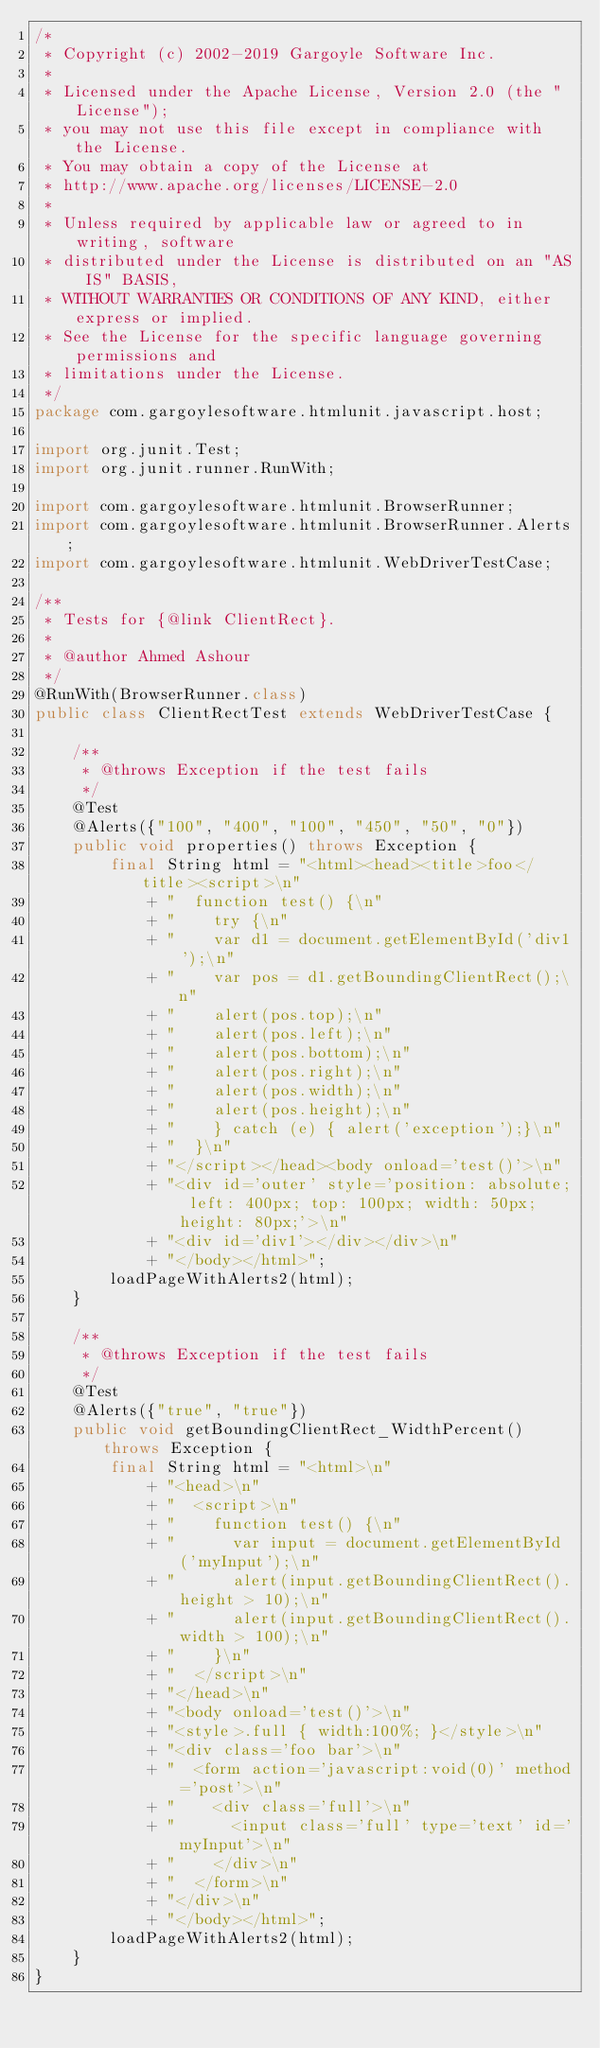<code> <loc_0><loc_0><loc_500><loc_500><_Java_>/*
 * Copyright (c) 2002-2019 Gargoyle Software Inc.
 *
 * Licensed under the Apache License, Version 2.0 (the "License");
 * you may not use this file except in compliance with the License.
 * You may obtain a copy of the License at
 * http://www.apache.org/licenses/LICENSE-2.0
 *
 * Unless required by applicable law or agreed to in writing, software
 * distributed under the License is distributed on an "AS IS" BASIS,
 * WITHOUT WARRANTIES OR CONDITIONS OF ANY KIND, either express or implied.
 * See the License for the specific language governing permissions and
 * limitations under the License.
 */
package com.gargoylesoftware.htmlunit.javascript.host;

import org.junit.Test;
import org.junit.runner.RunWith;

import com.gargoylesoftware.htmlunit.BrowserRunner;
import com.gargoylesoftware.htmlunit.BrowserRunner.Alerts;
import com.gargoylesoftware.htmlunit.WebDriverTestCase;

/**
 * Tests for {@link ClientRect}.
 *
 * @author Ahmed Ashour
 */
@RunWith(BrowserRunner.class)
public class ClientRectTest extends WebDriverTestCase {

    /**
     * @throws Exception if the test fails
     */
    @Test
    @Alerts({"100", "400", "100", "450", "50", "0"})
    public void properties() throws Exception {
        final String html = "<html><head><title>foo</title><script>\n"
            + "  function test() {\n"
            + "    try {\n"
            + "    var d1 = document.getElementById('div1');\n"
            + "    var pos = d1.getBoundingClientRect();\n"
            + "    alert(pos.top);\n"
            + "    alert(pos.left);\n"
            + "    alert(pos.bottom);\n"
            + "    alert(pos.right);\n"
            + "    alert(pos.width);\n"
            + "    alert(pos.height);\n"
            + "    } catch (e) { alert('exception');}\n"
            + "  }\n"
            + "</script></head><body onload='test()'>\n"
            + "<div id='outer' style='position: absolute; left: 400px; top: 100px; width: 50px; height: 80px;'>\n"
            + "<div id='div1'></div></div>\n"
            + "</body></html>";
        loadPageWithAlerts2(html);
    }

    /**
     * @throws Exception if the test fails
     */
    @Test
    @Alerts({"true", "true"})
    public void getBoundingClientRect_WidthPercent() throws Exception {
        final String html = "<html>\n"
            + "<head>\n"
            + "  <script>\n"
            + "    function test() {\n"
            + "      var input = document.getElementById('myInput');\n"
            + "      alert(input.getBoundingClientRect().height > 10);\n"
            + "      alert(input.getBoundingClientRect().width > 100);\n"
            + "    }\n"
            + "  </script>\n"
            + "</head>\n"
            + "<body onload='test()'>\n"
            + "<style>.full { width:100%; }</style>\n"
            + "<div class='foo bar'>\n"
            + "  <form action='javascript:void(0)' method='post'>\n"
            + "    <div class='full'>\n"
            + "      <input class='full' type='text' id='myInput'>\n"
            + "    </div>\n"
            + "  </form>\n"
            + "</div>\n"
            + "</body></html>";
        loadPageWithAlerts2(html);
    }
}
</code> 